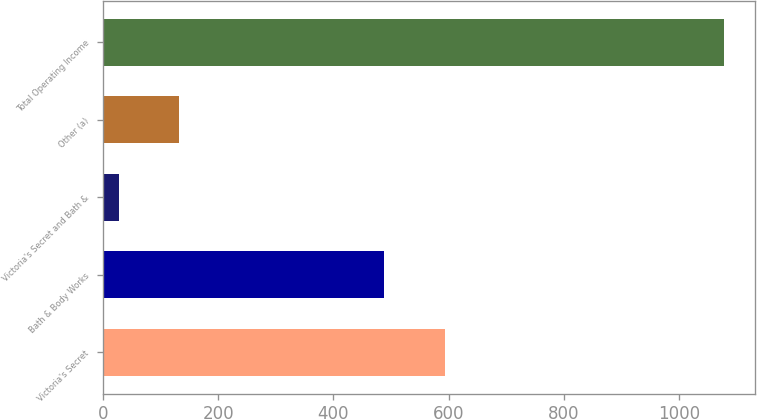Convert chart. <chart><loc_0><loc_0><loc_500><loc_500><bar_chart><fcel>Victoria's Secret<fcel>Bath & Body Works<fcel>Victoria's Secret and Bath &<fcel>Other (a)<fcel>Total Operating Income<nl><fcel>594<fcel>487<fcel>28<fcel>133<fcel>1078<nl></chart> 